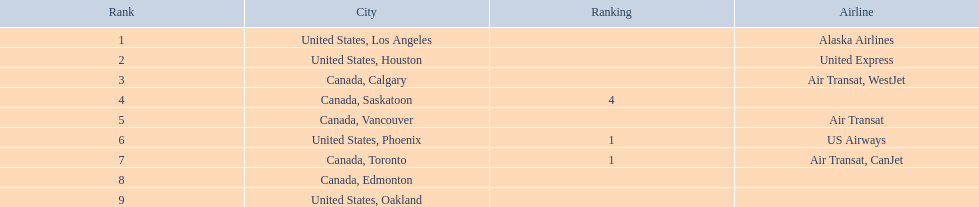What were all the passenger totals? 14,749, 5,465, 3,761, 2,282, 2,103, 1,829, 1,202, 110, 107. Which of these were to los angeles? 14,749. What other destination combined with this is closest to 19,000? Canada, Calgary. 